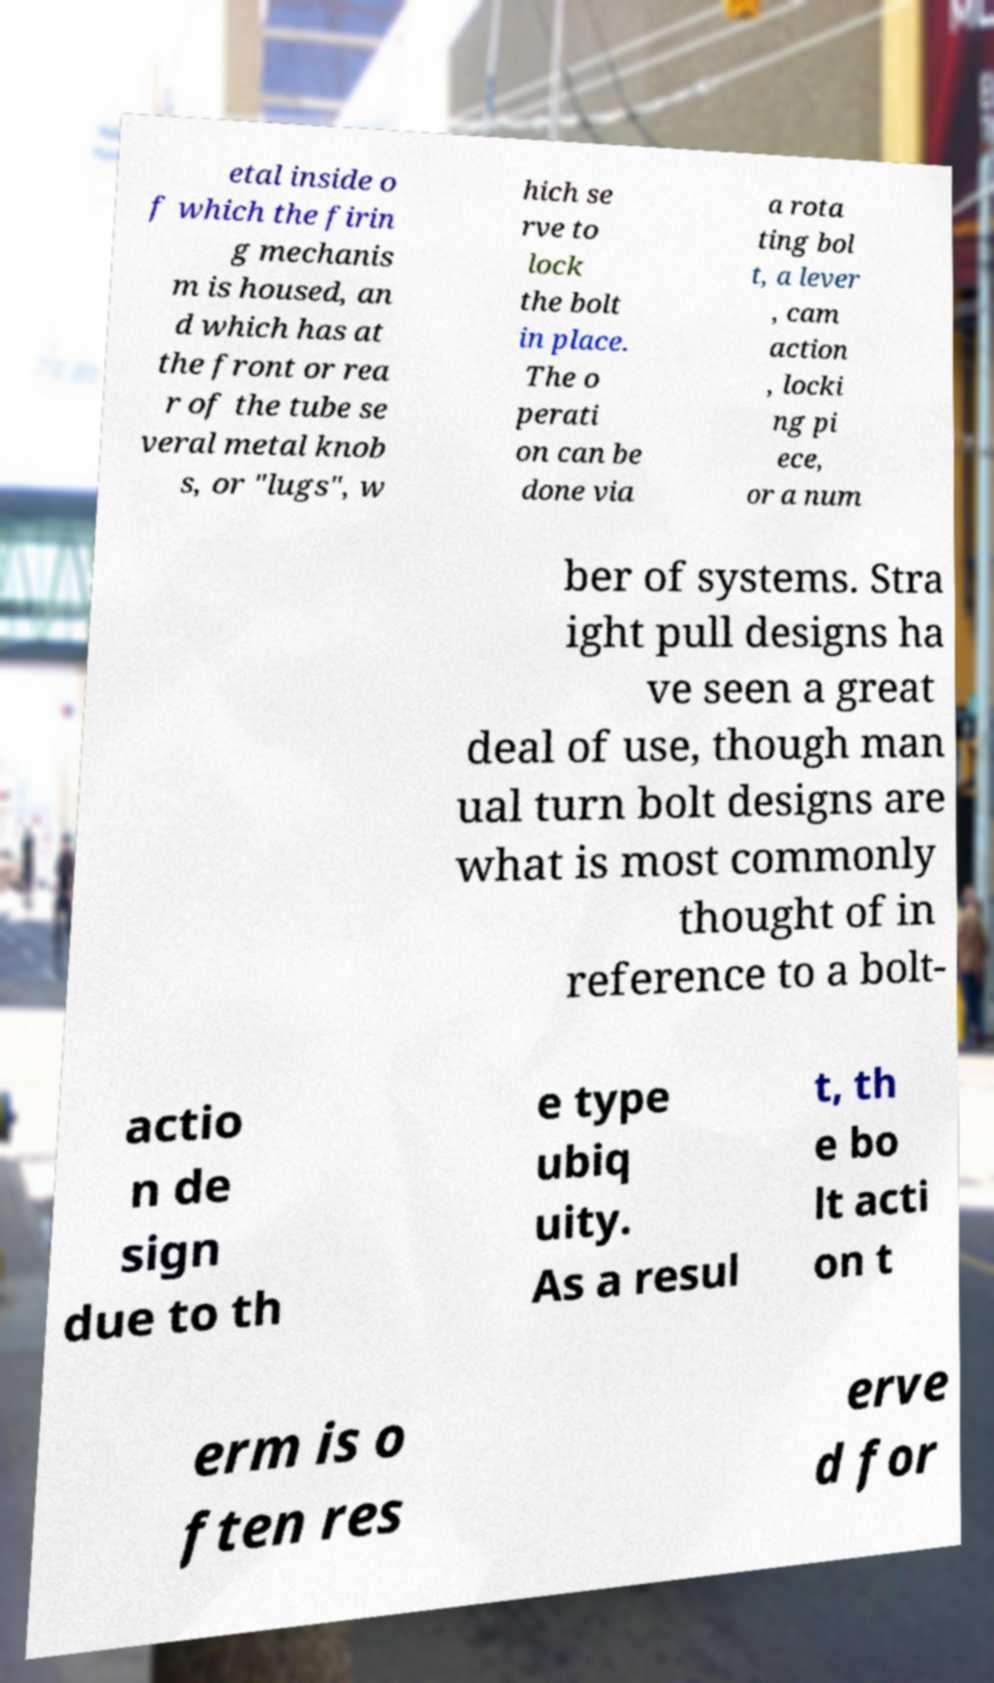Please identify and transcribe the text found in this image. etal inside o f which the firin g mechanis m is housed, an d which has at the front or rea r of the tube se veral metal knob s, or "lugs", w hich se rve to lock the bolt in place. The o perati on can be done via a rota ting bol t, a lever , cam action , locki ng pi ece, or a num ber of systems. Stra ight pull designs ha ve seen a great deal of use, though man ual turn bolt designs are what is most commonly thought of in reference to a bolt- actio n de sign due to th e type ubiq uity. As a resul t, th e bo lt acti on t erm is o ften res erve d for 